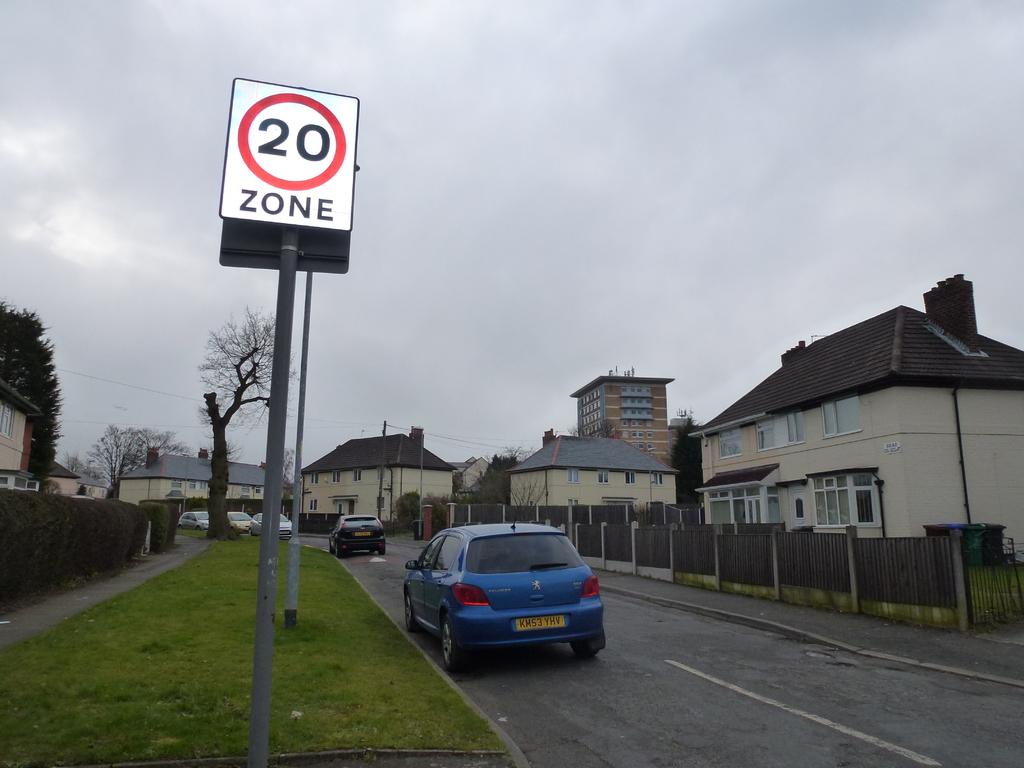How fast can cars drive in the zone pictured?
Offer a terse response. 20. What is the first letter of the license plate of the blue car?
Provide a succinct answer. K. 